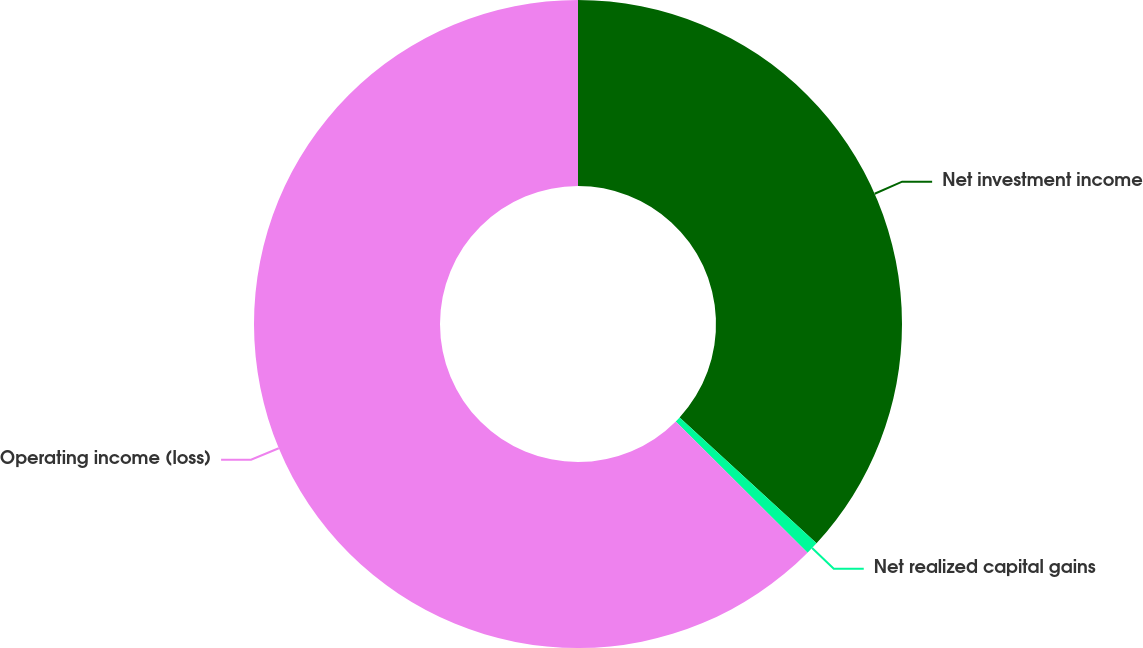Convert chart to OTSL. <chart><loc_0><loc_0><loc_500><loc_500><pie_chart><fcel>Net investment income<fcel>Net realized capital gains<fcel>Operating income (loss)<nl><fcel>36.83%<fcel>0.64%<fcel>62.53%<nl></chart> 